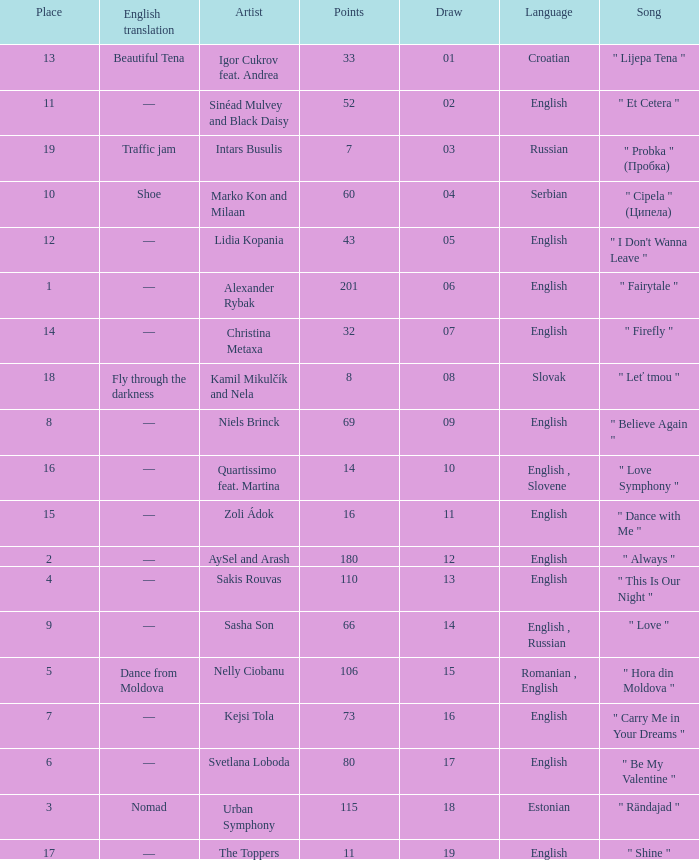What is the average Points when the artist is kamil mikulčík and nela, and the Place is larger than 18? None. 